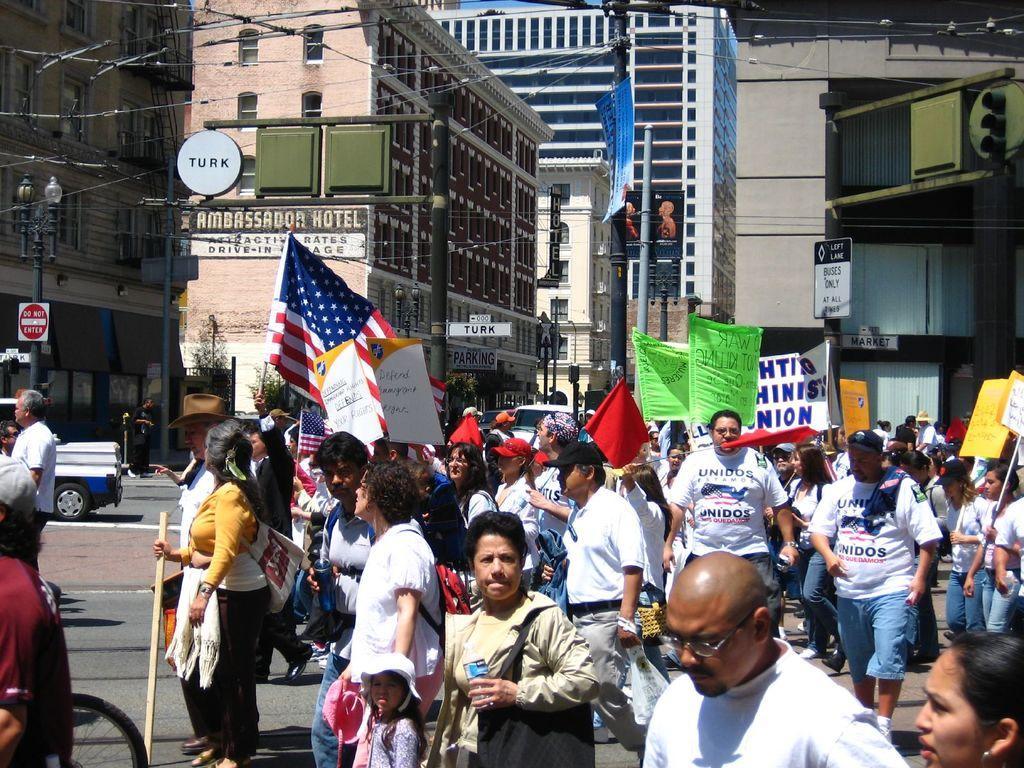Describe this image in one or two sentences. In this picture we can see a group of people on the road, flags, posters, name boards, poles, vehicles, trees, some objects and in the background we can see buildings with windows. 